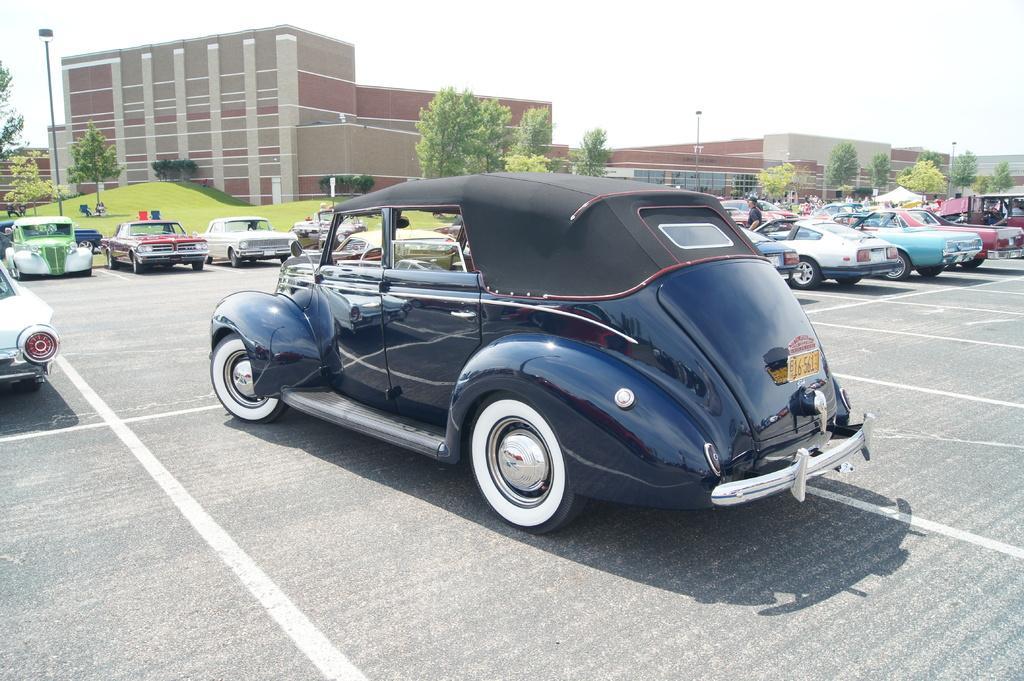In one or two sentences, can you explain what this image depicts? In this picture I can see vehicles on the road , there are group of people, a stall, a building, trees, poles, lights, chairs, and in the background there is sky. 